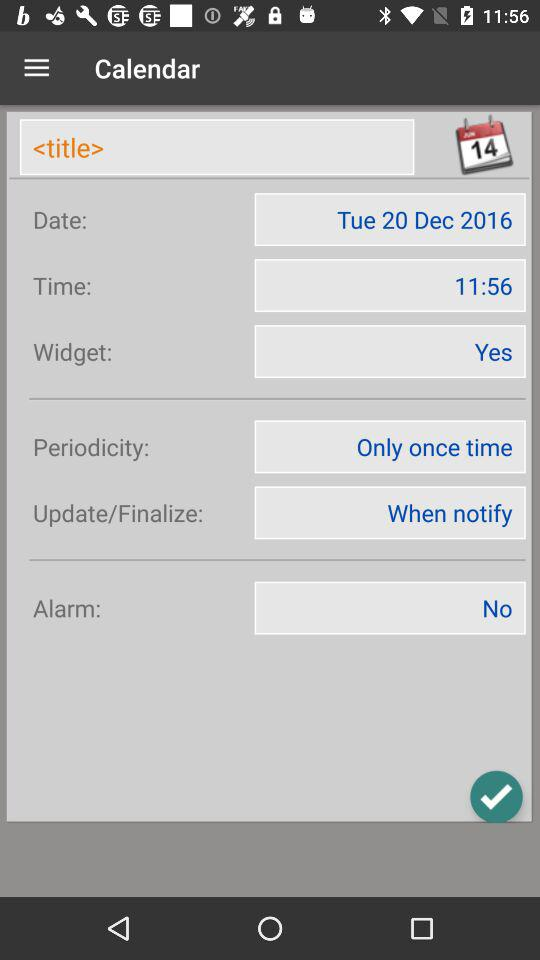What is the current setting for the alarm? The current setting for the alarm is "No". 